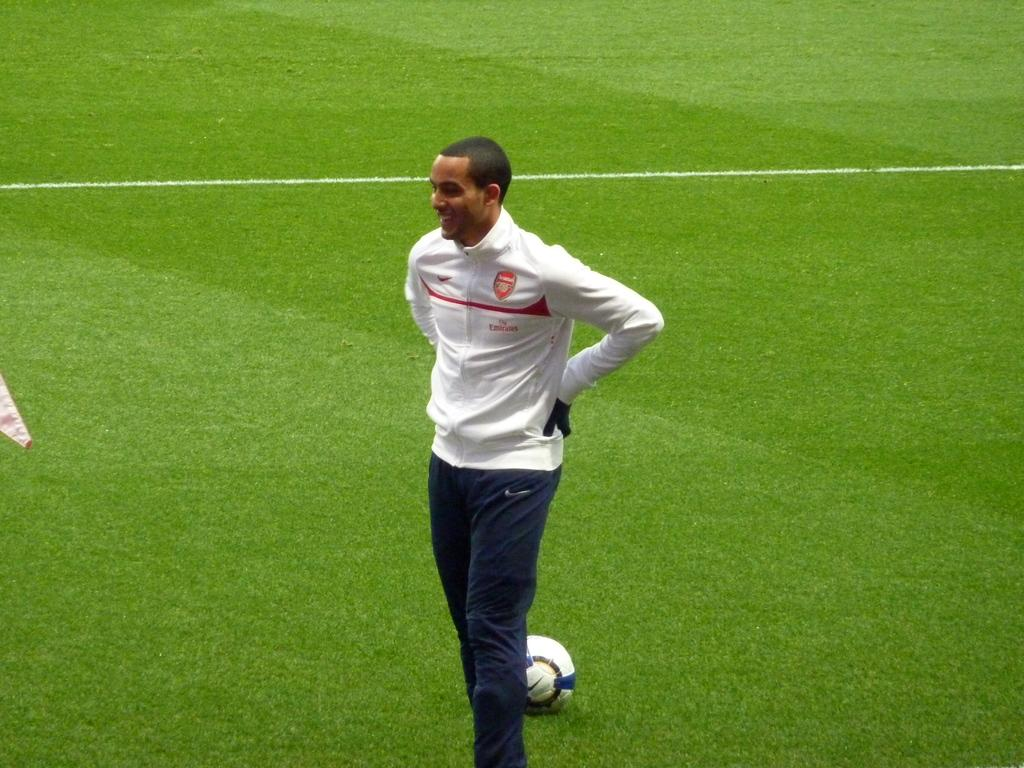Who is the main subject in the image? There is a boy in the image. Where is the boy positioned in the image? The boy is standing in the center of the image. What object can be seen at the bottom side of the image? There is a ball at the bottom side of the image. What type of surface is visible on the floor in the image? There is grassland on the floor in the image. What type of pig can be seen playing with the ball in the image? There is no pig present in the image; it features a boy standing in the center and a ball at the bottom side. What hope does the boy have for winning the game in the image? The image does not provide any information about a game or the boy's hopes for winning. 